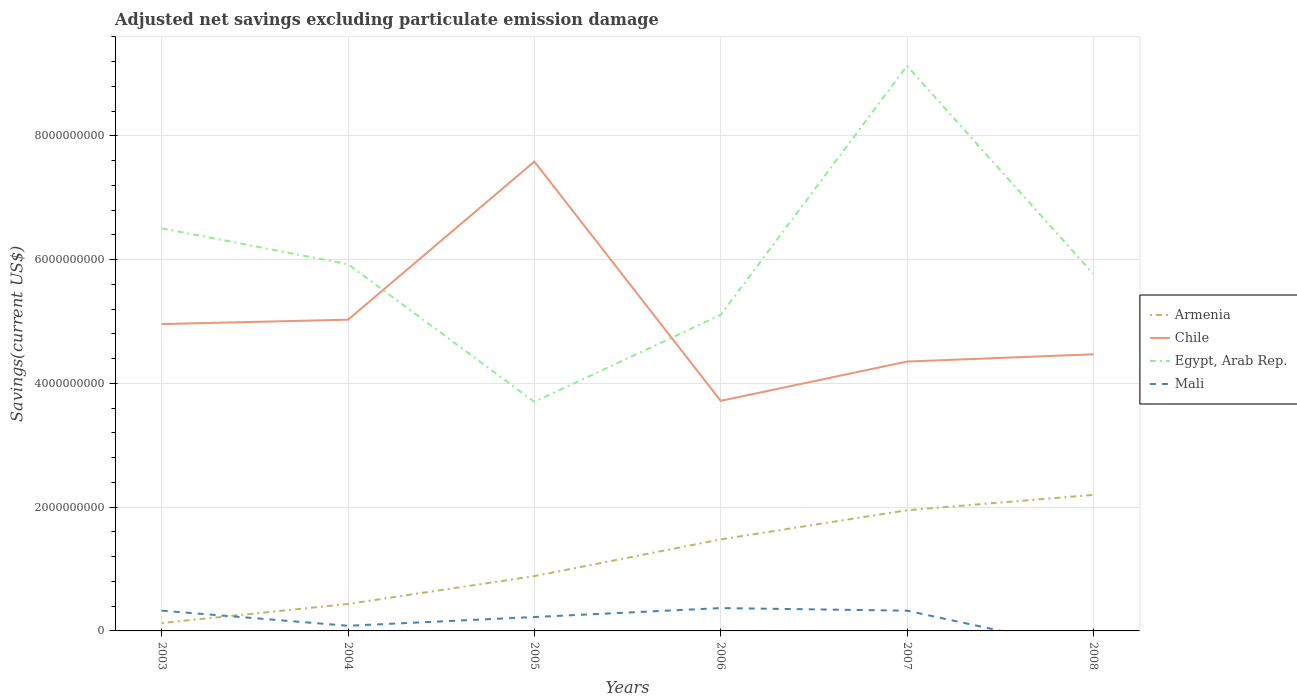Across all years, what is the maximum adjusted net savings in Mali?
Ensure brevity in your answer.  0. What is the total adjusted net savings in Armenia in the graph?
Offer a very short reply. -1.35e+09. What is the difference between the highest and the second highest adjusted net savings in Egypt, Arab Rep.?
Make the answer very short. 5.43e+09. What is the difference between the highest and the lowest adjusted net savings in Chile?
Your response must be concise. 2. Is the adjusted net savings in Mali strictly greater than the adjusted net savings in Chile over the years?
Your response must be concise. Yes. How many years are there in the graph?
Offer a terse response. 6. What is the difference between two consecutive major ticks on the Y-axis?
Ensure brevity in your answer.  2.00e+09. How are the legend labels stacked?
Your answer should be very brief. Vertical. What is the title of the graph?
Make the answer very short. Adjusted net savings excluding particulate emission damage. What is the label or title of the Y-axis?
Keep it short and to the point. Savings(current US$). What is the Savings(current US$) in Armenia in 2003?
Your answer should be very brief. 1.28e+08. What is the Savings(current US$) of Chile in 2003?
Offer a very short reply. 4.96e+09. What is the Savings(current US$) in Egypt, Arab Rep. in 2003?
Keep it short and to the point. 6.51e+09. What is the Savings(current US$) in Mali in 2003?
Provide a succinct answer. 3.28e+08. What is the Savings(current US$) of Armenia in 2004?
Provide a short and direct response. 4.36e+08. What is the Savings(current US$) of Chile in 2004?
Your answer should be compact. 5.03e+09. What is the Savings(current US$) of Egypt, Arab Rep. in 2004?
Ensure brevity in your answer.  5.93e+09. What is the Savings(current US$) in Mali in 2004?
Provide a short and direct response. 8.31e+07. What is the Savings(current US$) of Armenia in 2005?
Make the answer very short. 8.86e+08. What is the Savings(current US$) in Chile in 2005?
Give a very brief answer. 7.59e+09. What is the Savings(current US$) in Egypt, Arab Rep. in 2005?
Ensure brevity in your answer.  3.70e+09. What is the Savings(current US$) of Mali in 2005?
Give a very brief answer. 2.25e+08. What is the Savings(current US$) in Armenia in 2006?
Offer a very short reply. 1.48e+09. What is the Savings(current US$) of Chile in 2006?
Provide a succinct answer. 3.72e+09. What is the Savings(current US$) of Egypt, Arab Rep. in 2006?
Your response must be concise. 5.11e+09. What is the Savings(current US$) in Mali in 2006?
Your response must be concise. 3.69e+08. What is the Savings(current US$) of Armenia in 2007?
Ensure brevity in your answer.  1.95e+09. What is the Savings(current US$) in Chile in 2007?
Your answer should be compact. 4.35e+09. What is the Savings(current US$) of Egypt, Arab Rep. in 2007?
Provide a short and direct response. 9.13e+09. What is the Savings(current US$) of Mali in 2007?
Offer a terse response. 3.27e+08. What is the Savings(current US$) in Armenia in 2008?
Ensure brevity in your answer.  2.20e+09. What is the Savings(current US$) in Chile in 2008?
Offer a terse response. 4.47e+09. What is the Savings(current US$) of Egypt, Arab Rep. in 2008?
Ensure brevity in your answer.  5.77e+09. Across all years, what is the maximum Savings(current US$) of Armenia?
Your answer should be very brief. 2.20e+09. Across all years, what is the maximum Savings(current US$) of Chile?
Your answer should be very brief. 7.59e+09. Across all years, what is the maximum Savings(current US$) in Egypt, Arab Rep.?
Provide a succinct answer. 9.13e+09. Across all years, what is the maximum Savings(current US$) in Mali?
Make the answer very short. 3.69e+08. Across all years, what is the minimum Savings(current US$) of Armenia?
Your answer should be very brief. 1.28e+08. Across all years, what is the minimum Savings(current US$) in Chile?
Your response must be concise. 3.72e+09. Across all years, what is the minimum Savings(current US$) of Egypt, Arab Rep.?
Keep it short and to the point. 3.70e+09. Across all years, what is the minimum Savings(current US$) in Mali?
Your response must be concise. 0. What is the total Savings(current US$) of Armenia in the graph?
Offer a very short reply. 7.08e+09. What is the total Savings(current US$) in Chile in the graph?
Your answer should be very brief. 3.01e+1. What is the total Savings(current US$) in Egypt, Arab Rep. in the graph?
Provide a short and direct response. 3.61e+1. What is the total Savings(current US$) of Mali in the graph?
Keep it short and to the point. 1.33e+09. What is the difference between the Savings(current US$) of Armenia in 2003 and that in 2004?
Ensure brevity in your answer.  -3.08e+08. What is the difference between the Savings(current US$) of Chile in 2003 and that in 2004?
Offer a terse response. -7.09e+07. What is the difference between the Savings(current US$) of Egypt, Arab Rep. in 2003 and that in 2004?
Your answer should be very brief. 5.81e+08. What is the difference between the Savings(current US$) in Mali in 2003 and that in 2004?
Your answer should be compact. 2.45e+08. What is the difference between the Savings(current US$) in Armenia in 2003 and that in 2005?
Your response must be concise. -7.58e+08. What is the difference between the Savings(current US$) in Chile in 2003 and that in 2005?
Your response must be concise. -2.63e+09. What is the difference between the Savings(current US$) in Egypt, Arab Rep. in 2003 and that in 2005?
Offer a terse response. 2.80e+09. What is the difference between the Savings(current US$) of Mali in 2003 and that in 2005?
Your answer should be very brief. 1.03e+08. What is the difference between the Savings(current US$) in Armenia in 2003 and that in 2006?
Your answer should be compact. -1.35e+09. What is the difference between the Savings(current US$) of Chile in 2003 and that in 2006?
Ensure brevity in your answer.  1.24e+09. What is the difference between the Savings(current US$) of Egypt, Arab Rep. in 2003 and that in 2006?
Make the answer very short. 1.40e+09. What is the difference between the Savings(current US$) of Mali in 2003 and that in 2006?
Make the answer very short. -4.12e+07. What is the difference between the Savings(current US$) in Armenia in 2003 and that in 2007?
Offer a terse response. -1.82e+09. What is the difference between the Savings(current US$) in Chile in 2003 and that in 2007?
Give a very brief answer. 6.06e+08. What is the difference between the Savings(current US$) of Egypt, Arab Rep. in 2003 and that in 2007?
Provide a succinct answer. -2.63e+09. What is the difference between the Savings(current US$) in Mali in 2003 and that in 2007?
Keep it short and to the point. 7.09e+05. What is the difference between the Savings(current US$) in Armenia in 2003 and that in 2008?
Your response must be concise. -2.07e+09. What is the difference between the Savings(current US$) of Chile in 2003 and that in 2008?
Ensure brevity in your answer.  4.88e+08. What is the difference between the Savings(current US$) in Egypt, Arab Rep. in 2003 and that in 2008?
Offer a terse response. 7.39e+08. What is the difference between the Savings(current US$) in Armenia in 2004 and that in 2005?
Offer a terse response. -4.50e+08. What is the difference between the Savings(current US$) of Chile in 2004 and that in 2005?
Offer a very short reply. -2.56e+09. What is the difference between the Savings(current US$) of Egypt, Arab Rep. in 2004 and that in 2005?
Your answer should be compact. 2.22e+09. What is the difference between the Savings(current US$) of Mali in 2004 and that in 2005?
Provide a short and direct response. -1.42e+08. What is the difference between the Savings(current US$) of Armenia in 2004 and that in 2006?
Offer a terse response. -1.04e+09. What is the difference between the Savings(current US$) in Chile in 2004 and that in 2006?
Give a very brief answer. 1.31e+09. What is the difference between the Savings(current US$) of Egypt, Arab Rep. in 2004 and that in 2006?
Provide a short and direct response. 8.18e+08. What is the difference between the Savings(current US$) of Mali in 2004 and that in 2006?
Your answer should be compact. -2.86e+08. What is the difference between the Savings(current US$) of Armenia in 2004 and that in 2007?
Your answer should be very brief. -1.52e+09. What is the difference between the Savings(current US$) of Chile in 2004 and that in 2007?
Give a very brief answer. 6.77e+08. What is the difference between the Savings(current US$) in Egypt, Arab Rep. in 2004 and that in 2007?
Provide a short and direct response. -3.21e+09. What is the difference between the Savings(current US$) of Mali in 2004 and that in 2007?
Offer a terse response. -2.44e+08. What is the difference between the Savings(current US$) of Armenia in 2004 and that in 2008?
Offer a very short reply. -1.76e+09. What is the difference between the Savings(current US$) in Chile in 2004 and that in 2008?
Provide a short and direct response. 5.59e+08. What is the difference between the Savings(current US$) in Egypt, Arab Rep. in 2004 and that in 2008?
Keep it short and to the point. 1.58e+08. What is the difference between the Savings(current US$) in Armenia in 2005 and that in 2006?
Your answer should be compact. -5.93e+08. What is the difference between the Savings(current US$) in Chile in 2005 and that in 2006?
Your answer should be very brief. 3.87e+09. What is the difference between the Savings(current US$) of Egypt, Arab Rep. in 2005 and that in 2006?
Your answer should be very brief. -1.40e+09. What is the difference between the Savings(current US$) of Mali in 2005 and that in 2006?
Your answer should be compact. -1.44e+08. What is the difference between the Savings(current US$) in Armenia in 2005 and that in 2007?
Keep it short and to the point. -1.06e+09. What is the difference between the Savings(current US$) of Chile in 2005 and that in 2007?
Provide a short and direct response. 3.23e+09. What is the difference between the Savings(current US$) in Egypt, Arab Rep. in 2005 and that in 2007?
Ensure brevity in your answer.  -5.43e+09. What is the difference between the Savings(current US$) of Mali in 2005 and that in 2007?
Your response must be concise. -1.02e+08. What is the difference between the Savings(current US$) of Armenia in 2005 and that in 2008?
Give a very brief answer. -1.31e+09. What is the difference between the Savings(current US$) of Chile in 2005 and that in 2008?
Keep it short and to the point. 3.11e+09. What is the difference between the Savings(current US$) in Egypt, Arab Rep. in 2005 and that in 2008?
Provide a succinct answer. -2.07e+09. What is the difference between the Savings(current US$) of Armenia in 2006 and that in 2007?
Provide a short and direct response. -4.72e+08. What is the difference between the Savings(current US$) of Chile in 2006 and that in 2007?
Make the answer very short. -6.35e+08. What is the difference between the Savings(current US$) in Egypt, Arab Rep. in 2006 and that in 2007?
Your response must be concise. -4.03e+09. What is the difference between the Savings(current US$) of Mali in 2006 and that in 2007?
Keep it short and to the point. 4.19e+07. What is the difference between the Savings(current US$) of Armenia in 2006 and that in 2008?
Make the answer very short. -7.20e+08. What is the difference between the Savings(current US$) in Chile in 2006 and that in 2008?
Keep it short and to the point. -7.52e+08. What is the difference between the Savings(current US$) in Egypt, Arab Rep. in 2006 and that in 2008?
Provide a short and direct response. -6.61e+08. What is the difference between the Savings(current US$) of Armenia in 2007 and that in 2008?
Make the answer very short. -2.48e+08. What is the difference between the Savings(current US$) of Chile in 2007 and that in 2008?
Provide a succinct answer. -1.17e+08. What is the difference between the Savings(current US$) of Egypt, Arab Rep. in 2007 and that in 2008?
Make the answer very short. 3.37e+09. What is the difference between the Savings(current US$) in Armenia in 2003 and the Savings(current US$) in Chile in 2004?
Provide a succinct answer. -4.90e+09. What is the difference between the Savings(current US$) of Armenia in 2003 and the Savings(current US$) of Egypt, Arab Rep. in 2004?
Keep it short and to the point. -5.80e+09. What is the difference between the Savings(current US$) of Armenia in 2003 and the Savings(current US$) of Mali in 2004?
Make the answer very short. 4.49e+07. What is the difference between the Savings(current US$) of Chile in 2003 and the Savings(current US$) of Egypt, Arab Rep. in 2004?
Offer a very short reply. -9.66e+08. What is the difference between the Savings(current US$) in Chile in 2003 and the Savings(current US$) in Mali in 2004?
Your answer should be compact. 4.88e+09. What is the difference between the Savings(current US$) in Egypt, Arab Rep. in 2003 and the Savings(current US$) in Mali in 2004?
Ensure brevity in your answer.  6.42e+09. What is the difference between the Savings(current US$) in Armenia in 2003 and the Savings(current US$) in Chile in 2005?
Provide a short and direct response. -7.46e+09. What is the difference between the Savings(current US$) of Armenia in 2003 and the Savings(current US$) of Egypt, Arab Rep. in 2005?
Keep it short and to the point. -3.57e+09. What is the difference between the Savings(current US$) of Armenia in 2003 and the Savings(current US$) of Mali in 2005?
Offer a very short reply. -9.69e+07. What is the difference between the Savings(current US$) in Chile in 2003 and the Savings(current US$) in Egypt, Arab Rep. in 2005?
Offer a terse response. 1.26e+09. What is the difference between the Savings(current US$) in Chile in 2003 and the Savings(current US$) in Mali in 2005?
Offer a terse response. 4.73e+09. What is the difference between the Savings(current US$) in Egypt, Arab Rep. in 2003 and the Savings(current US$) in Mali in 2005?
Your answer should be compact. 6.28e+09. What is the difference between the Savings(current US$) in Armenia in 2003 and the Savings(current US$) in Chile in 2006?
Ensure brevity in your answer.  -3.59e+09. What is the difference between the Savings(current US$) of Armenia in 2003 and the Savings(current US$) of Egypt, Arab Rep. in 2006?
Offer a terse response. -4.98e+09. What is the difference between the Savings(current US$) of Armenia in 2003 and the Savings(current US$) of Mali in 2006?
Your answer should be compact. -2.41e+08. What is the difference between the Savings(current US$) in Chile in 2003 and the Savings(current US$) in Egypt, Arab Rep. in 2006?
Your response must be concise. -1.48e+08. What is the difference between the Savings(current US$) of Chile in 2003 and the Savings(current US$) of Mali in 2006?
Ensure brevity in your answer.  4.59e+09. What is the difference between the Savings(current US$) of Egypt, Arab Rep. in 2003 and the Savings(current US$) of Mali in 2006?
Ensure brevity in your answer.  6.14e+09. What is the difference between the Savings(current US$) of Armenia in 2003 and the Savings(current US$) of Chile in 2007?
Make the answer very short. -4.23e+09. What is the difference between the Savings(current US$) of Armenia in 2003 and the Savings(current US$) of Egypt, Arab Rep. in 2007?
Offer a very short reply. -9.01e+09. What is the difference between the Savings(current US$) of Armenia in 2003 and the Savings(current US$) of Mali in 2007?
Give a very brief answer. -1.99e+08. What is the difference between the Savings(current US$) in Chile in 2003 and the Savings(current US$) in Egypt, Arab Rep. in 2007?
Give a very brief answer. -4.17e+09. What is the difference between the Savings(current US$) in Chile in 2003 and the Savings(current US$) in Mali in 2007?
Provide a short and direct response. 4.63e+09. What is the difference between the Savings(current US$) in Egypt, Arab Rep. in 2003 and the Savings(current US$) in Mali in 2007?
Offer a terse response. 6.18e+09. What is the difference between the Savings(current US$) in Armenia in 2003 and the Savings(current US$) in Chile in 2008?
Offer a very short reply. -4.34e+09. What is the difference between the Savings(current US$) in Armenia in 2003 and the Savings(current US$) in Egypt, Arab Rep. in 2008?
Provide a short and direct response. -5.64e+09. What is the difference between the Savings(current US$) in Chile in 2003 and the Savings(current US$) in Egypt, Arab Rep. in 2008?
Make the answer very short. -8.09e+08. What is the difference between the Savings(current US$) in Armenia in 2004 and the Savings(current US$) in Chile in 2005?
Offer a terse response. -7.15e+09. What is the difference between the Savings(current US$) of Armenia in 2004 and the Savings(current US$) of Egypt, Arab Rep. in 2005?
Offer a terse response. -3.27e+09. What is the difference between the Savings(current US$) of Armenia in 2004 and the Savings(current US$) of Mali in 2005?
Your answer should be very brief. 2.11e+08. What is the difference between the Savings(current US$) of Chile in 2004 and the Savings(current US$) of Egypt, Arab Rep. in 2005?
Provide a short and direct response. 1.33e+09. What is the difference between the Savings(current US$) in Chile in 2004 and the Savings(current US$) in Mali in 2005?
Offer a terse response. 4.81e+09. What is the difference between the Savings(current US$) of Egypt, Arab Rep. in 2004 and the Savings(current US$) of Mali in 2005?
Keep it short and to the point. 5.70e+09. What is the difference between the Savings(current US$) of Armenia in 2004 and the Savings(current US$) of Chile in 2006?
Your answer should be very brief. -3.28e+09. What is the difference between the Savings(current US$) in Armenia in 2004 and the Savings(current US$) in Egypt, Arab Rep. in 2006?
Keep it short and to the point. -4.67e+09. What is the difference between the Savings(current US$) in Armenia in 2004 and the Savings(current US$) in Mali in 2006?
Your answer should be very brief. 6.64e+07. What is the difference between the Savings(current US$) in Chile in 2004 and the Savings(current US$) in Egypt, Arab Rep. in 2006?
Make the answer very short. -7.73e+07. What is the difference between the Savings(current US$) in Chile in 2004 and the Savings(current US$) in Mali in 2006?
Offer a very short reply. 4.66e+09. What is the difference between the Savings(current US$) of Egypt, Arab Rep. in 2004 and the Savings(current US$) of Mali in 2006?
Provide a short and direct response. 5.56e+09. What is the difference between the Savings(current US$) of Armenia in 2004 and the Savings(current US$) of Chile in 2007?
Ensure brevity in your answer.  -3.92e+09. What is the difference between the Savings(current US$) in Armenia in 2004 and the Savings(current US$) in Egypt, Arab Rep. in 2007?
Your answer should be very brief. -8.70e+09. What is the difference between the Savings(current US$) in Armenia in 2004 and the Savings(current US$) in Mali in 2007?
Provide a succinct answer. 1.08e+08. What is the difference between the Savings(current US$) of Chile in 2004 and the Savings(current US$) of Egypt, Arab Rep. in 2007?
Ensure brevity in your answer.  -4.10e+09. What is the difference between the Savings(current US$) in Chile in 2004 and the Savings(current US$) in Mali in 2007?
Your answer should be very brief. 4.70e+09. What is the difference between the Savings(current US$) of Egypt, Arab Rep. in 2004 and the Savings(current US$) of Mali in 2007?
Provide a short and direct response. 5.60e+09. What is the difference between the Savings(current US$) in Armenia in 2004 and the Savings(current US$) in Chile in 2008?
Give a very brief answer. -4.04e+09. What is the difference between the Savings(current US$) in Armenia in 2004 and the Savings(current US$) in Egypt, Arab Rep. in 2008?
Keep it short and to the point. -5.33e+09. What is the difference between the Savings(current US$) in Chile in 2004 and the Savings(current US$) in Egypt, Arab Rep. in 2008?
Offer a very short reply. -7.38e+08. What is the difference between the Savings(current US$) of Armenia in 2005 and the Savings(current US$) of Chile in 2006?
Your response must be concise. -2.83e+09. What is the difference between the Savings(current US$) in Armenia in 2005 and the Savings(current US$) in Egypt, Arab Rep. in 2006?
Your response must be concise. -4.22e+09. What is the difference between the Savings(current US$) in Armenia in 2005 and the Savings(current US$) in Mali in 2006?
Ensure brevity in your answer.  5.17e+08. What is the difference between the Savings(current US$) in Chile in 2005 and the Savings(current US$) in Egypt, Arab Rep. in 2006?
Provide a short and direct response. 2.48e+09. What is the difference between the Savings(current US$) in Chile in 2005 and the Savings(current US$) in Mali in 2006?
Offer a very short reply. 7.22e+09. What is the difference between the Savings(current US$) of Egypt, Arab Rep. in 2005 and the Savings(current US$) of Mali in 2006?
Make the answer very short. 3.33e+09. What is the difference between the Savings(current US$) in Armenia in 2005 and the Savings(current US$) in Chile in 2007?
Provide a short and direct response. -3.47e+09. What is the difference between the Savings(current US$) in Armenia in 2005 and the Savings(current US$) in Egypt, Arab Rep. in 2007?
Your answer should be compact. -8.25e+09. What is the difference between the Savings(current US$) in Armenia in 2005 and the Savings(current US$) in Mali in 2007?
Offer a very short reply. 5.59e+08. What is the difference between the Savings(current US$) of Chile in 2005 and the Savings(current US$) of Egypt, Arab Rep. in 2007?
Your answer should be compact. -1.55e+09. What is the difference between the Savings(current US$) in Chile in 2005 and the Savings(current US$) in Mali in 2007?
Your response must be concise. 7.26e+09. What is the difference between the Savings(current US$) in Egypt, Arab Rep. in 2005 and the Savings(current US$) in Mali in 2007?
Provide a short and direct response. 3.38e+09. What is the difference between the Savings(current US$) in Armenia in 2005 and the Savings(current US$) in Chile in 2008?
Your answer should be compact. -3.58e+09. What is the difference between the Savings(current US$) of Armenia in 2005 and the Savings(current US$) of Egypt, Arab Rep. in 2008?
Provide a short and direct response. -4.88e+09. What is the difference between the Savings(current US$) of Chile in 2005 and the Savings(current US$) of Egypt, Arab Rep. in 2008?
Keep it short and to the point. 1.82e+09. What is the difference between the Savings(current US$) of Armenia in 2006 and the Savings(current US$) of Chile in 2007?
Provide a short and direct response. -2.87e+09. What is the difference between the Savings(current US$) of Armenia in 2006 and the Savings(current US$) of Egypt, Arab Rep. in 2007?
Your answer should be compact. -7.65e+09. What is the difference between the Savings(current US$) of Armenia in 2006 and the Savings(current US$) of Mali in 2007?
Your answer should be very brief. 1.15e+09. What is the difference between the Savings(current US$) in Chile in 2006 and the Savings(current US$) in Egypt, Arab Rep. in 2007?
Offer a terse response. -5.41e+09. What is the difference between the Savings(current US$) in Chile in 2006 and the Savings(current US$) in Mali in 2007?
Ensure brevity in your answer.  3.39e+09. What is the difference between the Savings(current US$) of Egypt, Arab Rep. in 2006 and the Savings(current US$) of Mali in 2007?
Make the answer very short. 4.78e+09. What is the difference between the Savings(current US$) of Armenia in 2006 and the Savings(current US$) of Chile in 2008?
Offer a very short reply. -2.99e+09. What is the difference between the Savings(current US$) in Armenia in 2006 and the Savings(current US$) in Egypt, Arab Rep. in 2008?
Keep it short and to the point. -4.29e+09. What is the difference between the Savings(current US$) of Chile in 2006 and the Savings(current US$) of Egypt, Arab Rep. in 2008?
Ensure brevity in your answer.  -2.05e+09. What is the difference between the Savings(current US$) in Armenia in 2007 and the Savings(current US$) in Chile in 2008?
Your response must be concise. -2.52e+09. What is the difference between the Savings(current US$) in Armenia in 2007 and the Savings(current US$) in Egypt, Arab Rep. in 2008?
Keep it short and to the point. -3.82e+09. What is the difference between the Savings(current US$) in Chile in 2007 and the Savings(current US$) in Egypt, Arab Rep. in 2008?
Ensure brevity in your answer.  -1.41e+09. What is the average Savings(current US$) of Armenia per year?
Give a very brief answer. 1.18e+09. What is the average Savings(current US$) of Chile per year?
Your answer should be compact. 5.02e+09. What is the average Savings(current US$) in Egypt, Arab Rep. per year?
Your answer should be compact. 6.02e+09. What is the average Savings(current US$) in Mali per year?
Offer a very short reply. 2.22e+08. In the year 2003, what is the difference between the Savings(current US$) of Armenia and Savings(current US$) of Chile?
Offer a terse response. -4.83e+09. In the year 2003, what is the difference between the Savings(current US$) of Armenia and Savings(current US$) of Egypt, Arab Rep.?
Your answer should be compact. -6.38e+09. In the year 2003, what is the difference between the Savings(current US$) in Armenia and Savings(current US$) in Mali?
Make the answer very short. -2.00e+08. In the year 2003, what is the difference between the Savings(current US$) in Chile and Savings(current US$) in Egypt, Arab Rep.?
Your answer should be compact. -1.55e+09. In the year 2003, what is the difference between the Savings(current US$) of Chile and Savings(current US$) of Mali?
Make the answer very short. 4.63e+09. In the year 2003, what is the difference between the Savings(current US$) in Egypt, Arab Rep. and Savings(current US$) in Mali?
Keep it short and to the point. 6.18e+09. In the year 2004, what is the difference between the Savings(current US$) of Armenia and Savings(current US$) of Chile?
Your response must be concise. -4.59e+09. In the year 2004, what is the difference between the Savings(current US$) in Armenia and Savings(current US$) in Egypt, Arab Rep.?
Offer a terse response. -5.49e+09. In the year 2004, what is the difference between the Savings(current US$) of Armenia and Savings(current US$) of Mali?
Offer a very short reply. 3.52e+08. In the year 2004, what is the difference between the Savings(current US$) in Chile and Savings(current US$) in Egypt, Arab Rep.?
Your answer should be compact. -8.96e+08. In the year 2004, what is the difference between the Savings(current US$) in Chile and Savings(current US$) in Mali?
Offer a very short reply. 4.95e+09. In the year 2004, what is the difference between the Savings(current US$) of Egypt, Arab Rep. and Savings(current US$) of Mali?
Provide a succinct answer. 5.84e+09. In the year 2005, what is the difference between the Savings(current US$) in Armenia and Savings(current US$) in Chile?
Your answer should be compact. -6.70e+09. In the year 2005, what is the difference between the Savings(current US$) in Armenia and Savings(current US$) in Egypt, Arab Rep.?
Keep it short and to the point. -2.82e+09. In the year 2005, what is the difference between the Savings(current US$) in Armenia and Savings(current US$) in Mali?
Offer a terse response. 6.61e+08. In the year 2005, what is the difference between the Savings(current US$) in Chile and Savings(current US$) in Egypt, Arab Rep.?
Keep it short and to the point. 3.88e+09. In the year 2005, what is the difference between the Savings(current US$) of Chile and Savings(current US$) of Mali?
Offer a terse response. 7.36e+09. In the year 2005, what is the difference between the Savings(current US$) of Egypt, Arab Rep. and Savings(current US$) of Mali?
Offer a terse response. 3.48e+09. In the year 2006, what is the difference between the Savings(current US$) of Armenia and Savings(current US$) of Chile?
Give a very brief answer. -2.24e+09. In the year 2006, what is the difference between the Savings(current US$) in Armenia and Savings(current US$) in Egypt, Arab Rep.?
Offer a very short reply. -3.63e+09. In the year 2006, what is the difference between the Savings(current US$) in Armenia and Savings(current US$) in Mali?
Provide a short and direct response. 1.11e+09. In the year 2006, what is the difference between the Savings(current US$) of Chile and Savings(current US$) of Egypt, Arab Rep.?
Provide a succinct answer. -1.39e+09. In the year 2006, what is the difference between the Savings(current US$) of Chile and Savings(current US$) of Mali?
Give a very brief answer. 3.35e+09. In the year 2006, what is the difference between the Savings(current US$) of Egypt, Arab Rep. and Savings(current US$) of Mali?
Offer a terse response. 4.74e+09. In the year 2007, what is the difference between the Savings(current US$) of Armenia and Savings(current US$) of Chile?
Offer a terse response. -2.40e+09. In the year 2007, what is the difference between the Savings(current US$) of Armenia and Savings(current US$) of Egypt, Arab Rep.?
Keep it short and to the point. -7.18e+09. In the year 2007, what is the difference between the Savings(current US$) of Armenia and Savings(current US$) of Mali?
Your answer should be compact. 1.62e+09. In the year 2007, what is the difference between the Savings(current US$) in Chile and Savings(current US$) in Egypt, Arab Rep.?
Ensure brevity in your answer.  -4.78e+09. In the year 2007, what is the difference between the Savings(current US$) in Chile and Savings(current US$) in Mali?
Keep it short and to the point. 4.03e+09. In the year 2007, what is the difference between the Savings(current US$) of Egypt, Arab Rep. and Savings(current US$) of Mali?
Offer a very short reply. 8.81e+09. In the year 2008, what is the difference between the Savings(current US$) of Armenia and Savings(current US$) of Chile?
Ensure brevity in your answer.  -2.27e+09. In the year 2008, what is the difference between the Savings(current US$) of Armenia and Savings(current US$) of Egypt, Arab Rep.?
Provide a succinct answer. -3.57e+09. In the year 2008, what is the difference between the Savings(current US$) of Chile and Savings(current US$) of Egypt, Arab Rep.?
Keep it short and to the point. -1.30e+09. What is the ratio of the Savings(current US$) of Armenia in 2003 to that in 2004?
Your answer should be compact. 0.29. What is the ratio of the Savings(current US$) in Chile in 2003 to that in 2004?
Your response must be concise. 0.99. What is the ratio of the Savings(current US$) in Egypt, Arab Rep. in 2003 to that in 2004?
Give a very brief answer. 1.1. What is the ratio of the Savings(current US$) of Mali in 2003 to that in 2004?
Make the answer very short. 3.95. What is the ratio of the Savings(current US$) in Armenia in 2003 to that in 2005?
Provide a succinct answer. 0.14. What is the ratio of the Savings(current US$) of Chile in 2003 to that in 2005?
Give a very brief answer. 0.65. What is the ratio of the Savings(current US$) in Egypt, Arab Rep. in 2003 to that in 2005?
Your answer should be compact. 1.76. What is the ratio of the Savings(current US$) of Mali in 2003 to that in 2005?
Give a very brief answer. 1.46. What is the ratio of the Savings(current US$) in Armenia in 2003 to that in 2006?
Keep it short and to the point. 0.09. What is the ratio of the Savings(current US$) of Chile in 2003 to that in 2006?
Provide a short and direct response. 1.33. What is the ratio of the Savings(current US$) in Egypt, Arab Rep. in 2003 to that in 2006?
Keep it short and to the point. 1.27. What is the ratio of the Savings(current US$) of Mali in 2003 to that in 2006?
Make the answer very short. 0.89. What is the ratio of the Savings(current US$) in Armenia in 2003 to that in 2007?
Your answer should be very brief. 0.07. What is the ratio of the Savings(current US$) in Chile in 2003 to that in 2007?
Give a very brief answer. 1.14. What is the ratio of the Savings(current US$) of Egypt, Arab Rep. in 2003 to that in 2007?
Your answer should be compact. 0.71. What is the ratio of the Savings(current US$) of Mali in 2003 to that in 2007?
Offer a very short reply. 1. What is the ratio of the Savings(current US$) of Armenia in 2003 to that in 2008?
Your response must be concise. 0.06. What is the ratio of the Savings(current US$) in Chile in 2003 to that in 2008?
Offer a very short reply. 1.11. What is the ratio of the Savings(current US$) in Egypt, Arab Rep. in 2003 to that in 2008?
Your answer should be compact. 1.13. What is the ratio of the Savings(current US$) of Armenia in 2004 to that in 2005?
Your response must be concise. 0.49. What is the ratio of the Savings(current US$) in Chile in 2004 to that in 2005?
Provide a succinct answer. 0.66. What is the ratio of the Savings(current US$) of Egypt, Arab Rep. in 2004 to that in 2005?
Ensure brevity in your answer.  1.6. What is the ratio of the Savings(current US$) in Mali in 2004 to that in 2005?
Offer a very short reply. 0.37. What is the ratio of the Savings(current US$) in Armenia in 2004 to that in 2006?
Your response must be concise. 0.29. What is the ratio of the Savings(current US$) of Chile in 2004 to that in 2006?
Your answer should be compact. 1.35. What is the ratio of the Savings(current US$) in Egypt, Arab Rep. in 2004 to that in 2006?
Make the answer very short. 1.16. What is the ratio of the Savings(current US$) in Mali in 2004 to that in 2006?
Ensure brevity in your answer.  0.23. What is the ratio of the Savings(current US$) of Armenia in 2004 to that in 2007?
Offer a very short reply. 0.22. What is the ratio of the Savings(current US$) in Chile in 2004 to that in 2007?
Your answer should be very brief. 1.16. What is the ratio of the Savings(current US$) in Egypt, Arab Rep. in 2004 to that in 2007?
Keep it short and to the point. 0.65. What is the ratio of the Savings(current US$) in Mali in 2004 to that in 2007?
Your answer should be very brief. 0.25. What is the ratio of the Savings(current US$) in Armenia in 2004 to that in 2008?
Your answer should be compact. 0.2. What is the ratio of the Savings(current US$) of Chile in 2004 to that in 2008?
Ensure brevity in your answer.  1.13. What is the ratio of the Savings(current US$) of Egypt, Arab Rep. in 2004 to that in 2008?
Keep it short and to the point. 1.03. What is the ratio of the Savings(current US$) of Armenia in 2005 to that in 2006?
Provide a short and direct response. 0.6. What is the ratio of the Savings(current US$) in Chile in 2005 to that in 2006?
Provide a succinct answer. 2.04. What is the ratio of the Savings(current US$) in Egypt, Arab Rep. in 2005 to that in 2006?
Offer a very short reply. 0.72. What is the ratio of the Savings(current US$) of Mali in 2005 to that in 2006?
Ensure brevity in your answer.  0.61. What is the ratio of the Savings(current US$) of Armenia in 2005 to that in 2007?
Ensure brevity in your answer.  0.45. What is the ratio of the Savings(current US$) in Chile in 2005 to that in 2007?
Offer a very short reply. 1.74. What is the ratio of the Savings(current US$) of Egypt, Arab Rep. in 2005 to that in 2007?
Make the answer very short. 0.41. What is the ratio of the Savings(current US$) of Mali in 2005 to that in 2007?
Make the answer very short. 0.69. What is the ratio of the Savings(current US$) in Armenia in 2005 to that in 2008?
Ensure brevity in your answer.  0.4. What is the ratio of the Savings(current US$) in Chile in 2005 to that in 2008?
Your answer should be very brief. 1.7. What is the ratio of the Savings(current US$) in Egypt, Arab Rep. in 2005 to that in 2008?
Your response must be concise. 0.64. What is the ratio of the Savings(current US$) of Armenia in 2006 to that in 2007?
Ensure brevity in your answer.  0.76. What is the ratio of the Savings(current US$) in Chile in 2006 to that in 2007?
Provide a short and direct response. 0.85. What is the ratio of the Savings(current US$) in Egypt, Arab Rep. in 2006 to that in 2007?
Keep it short and to the point. 0.56. What is the ratio of the Savings(current US$) in Mali in 2006 to that in 2007?
Ensure brevity in your answer.  1.13. What is the ratio of the Savings(current US$) in Armenia in 2006 to that in 2008?
Provide a short and direct response. 0.67. What is the ratio of the Savings(current US$) in Chile in 2006 to that in 2008?
Provide a succinct answer. 0.83. What is the ratio of the Savings(current US$) in Egypt, Arab Rep. in 2006 to that in 2008?
Offer a very short reply. 0.89. What is the ratio of the Savings(current US$) of Armenia in 2007 to that in 2008?
Provide a succinct answer. 0.89. What is the ratio of the Savings(current US$) in Chile in 2007 to that in 2008?
Give a very brief answer. 0.97. What is the ratio of the Savings(current US$) of Egypt, Arab Rep. in 2007 to that in 2008?
Your answer should be compact. 1.58. What is the difference between the highest and the second highest Savings(current US$) of Armenia?
Provide a succinct answer. 2.48e+08. What is the difference between the highest and the second highest Savings(current US$) in Chile?
Ensure brevity in your answer.  2.56e+09. What is the difference between the highest and the second highest Savings(current US$) in Egypt, Arab Rep.?
Ensure brevity in your answer.  2.63e+09. What is the difference between the highest and the second highest Savings(current US$) of Mali?
Provide a short and direct response. 4.12e+07. What is the difference between the highest and the lowest Savings(current US$) of Armenia?
Your response must be concise. 2.07e+09. What is the difference between the highest and the lowest Savings(current US$) in Chile?
Offer a terse response. 3.87e+09. What is the difference between the highest and the lowest Savings(current US$) of Egypt, Arab Rep.?
Your response must be concise. 5.43e+09. What is the difference between the highest and the lowest Savings(current US$) in Mali?
Your answer should be compact. 3.69e+08. 